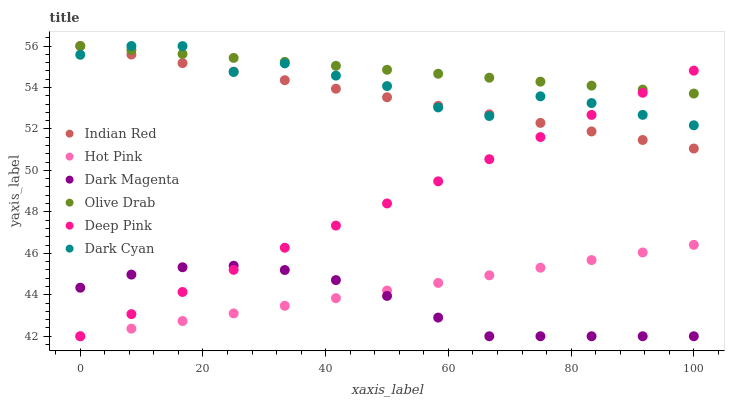Does Dark Magenta have the minimum area under the curve?
Answer yes or no. Yes. Does Olive Drab have the maximum area under the curve?
Answer yes or no. Yes. Does Hot Pink have the minimum area under the curve?
Answer yes or no. No. Does Hot Pink have the maximum area under the curve?
Answer yes or no. No. Is Indian Red the smoothest?
Answer yes or no. Yes. Is Dark Cyan the roughest?
Answer yes or no. Yes. Is Dark Magenta the smoothest?
Answer yes or no. No. Is Dark Magenta the roughest?
Answer yes or no. No. Does Deep Pink have the lowest value?
Answer yes or no. Yes. Does Indian Red have the lowest value?
Answer yes or no. No. Does Olive Drab have the highest value?
Answer yes or no. Yes. Does Hot Pink have the highest value?
Answer yes or no. No. Is Hot Pink less than Dark Cyan?
Answer yes or no. Yes. Is Olive Drab greater than Dark Magenta?
Answer yes or no. Yes. Does Olive Drab intersect Dark Cyan?
Answer yes or no. Yes. Is Olive Drab less than Dark Cyan?
Answer yes or no. No. Is Olive Drab greater than Dark Cyan?
Answer yes or no. No. Does Hot Pink intersect Dark Cyan?
Answer yes or no. No. 